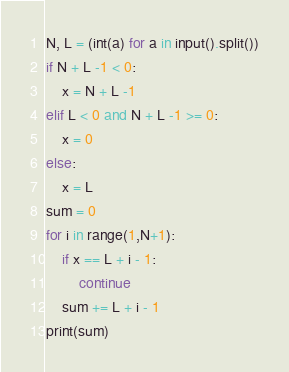<code> <loc_0><loc_0><loc_500><loc_500><_Python_>N, L = (int(a) for a in input().split())
if N + L -1 < 0:
    x = N + L -1
elif L < 0 and N + L -1 >= 0:
    x = 0
else:
    x = L
sum = 0
for i in range(1,N+1):
    if x == L + i - 1:
        continue
    sum += L + i - 1
print(sum)</code> 